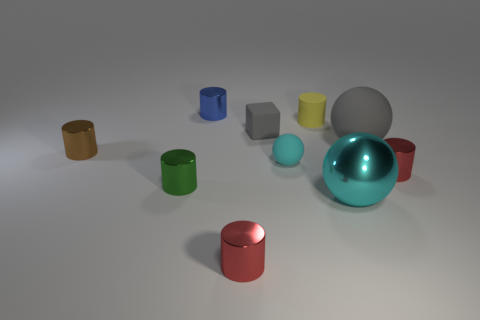How many cyan spheres must be subtracted to get 1 cyan spheres? 1 Subtract all green cylinders. How many cylinders are left? 5 Subtract all green cylinders. How many cylinders are left? 5 Subtract all blue cylinders. Subtract all yellow blocks. How many cylinders are left? 5 Subtract all balls. How many objects are left? 7 Add 7 gray objects. How many gray objects exist? 9 Subtract 0 blue cubes. How many objects are left? 10 Subtract all small brown cylinders. Subtract all small blue shiny cylinders. How many objects are left? 8 Add 3 large objects. How many large objects are left? 5 